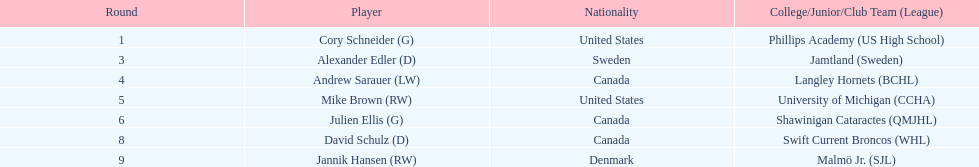How many canadian players are listed? 3. 